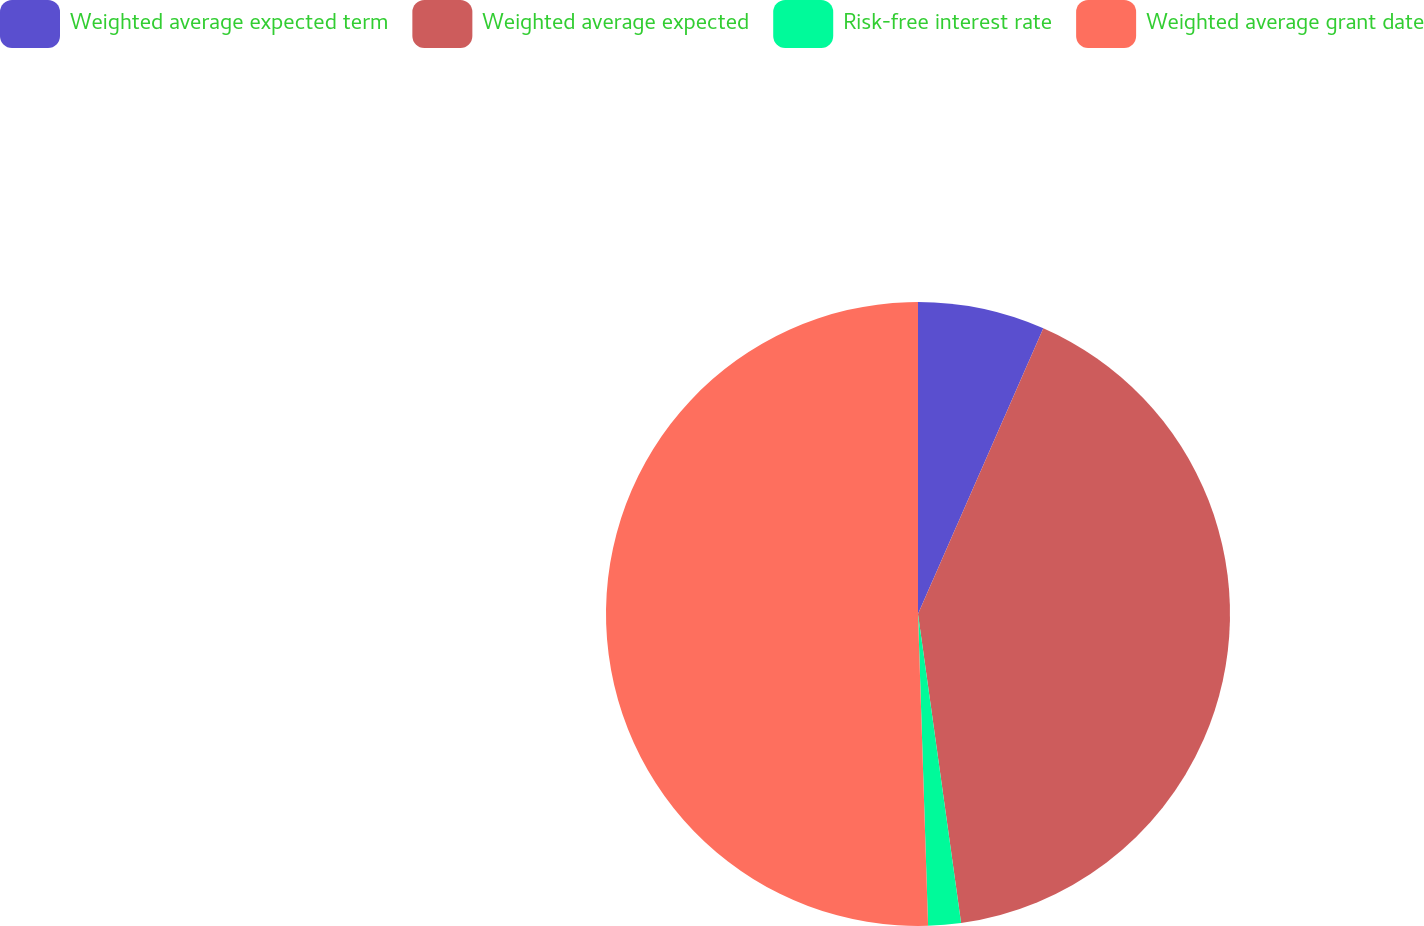<chart> <loc_0><loc_0><loc_500><loc_500><pie_chart><fcel>Weighted average expected term<fcel>Weighted average expected<fcel>Risk-free interest rate<fcel>Weighted average grant date<nl><fcel>6.58%<fcel>41.22%<fcel>1.69%<fcel>50.52%<nl></chart> 